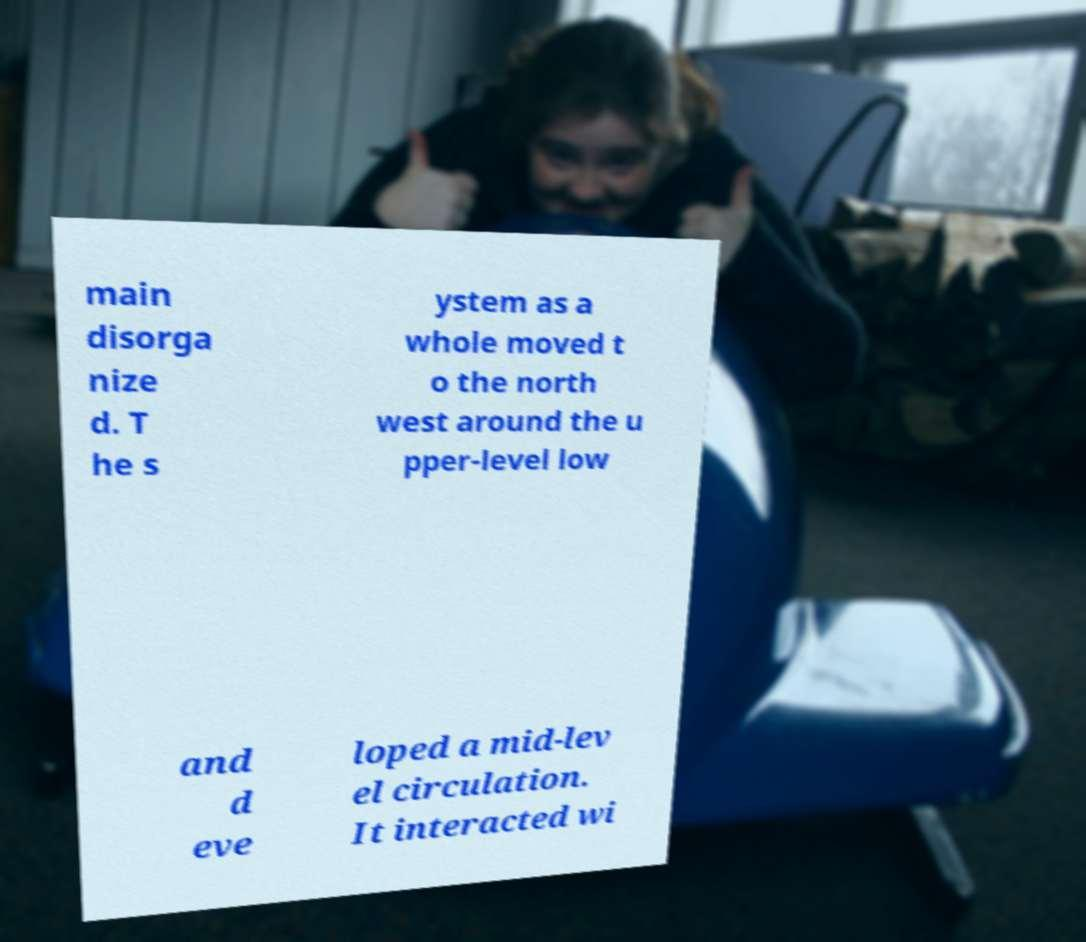Could you assist in decoding the text presented in this image and type it out clearly? main disorga nize d. T he s ystem as a whole moved t o the north west around the u pper-level low and d eve loped a mid-lev el circulation. It interacted wi 